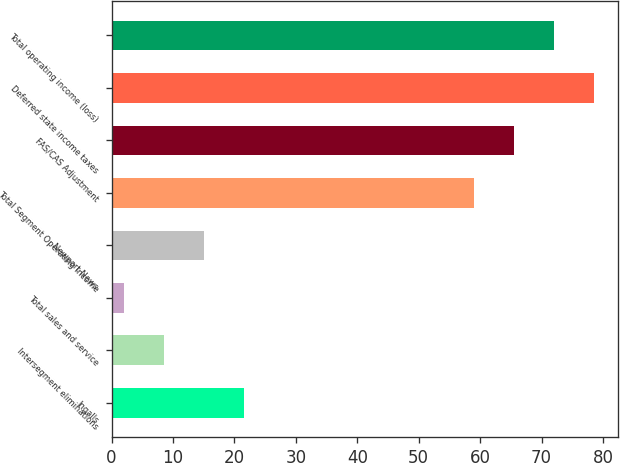Convert chart. <chart><loc_0><loc_0><loc_500><loc_500><bar_chart><fcel>Ingalls<fcel>Intersegment eliminations<fcel>Total sales and service<fcel>Newport News<fcel>Total Segment Operating Income<fcel>FAS/CAS Adjustment<fcel>Deferred state income taxes<fcel>Total operating income (loss)<nl><fcel>21.5<fcel>8.5<fcel>2<fcel>15<fcel>59<fcel>65.5<fcel>78.5<fcel>72<nl></chart> 